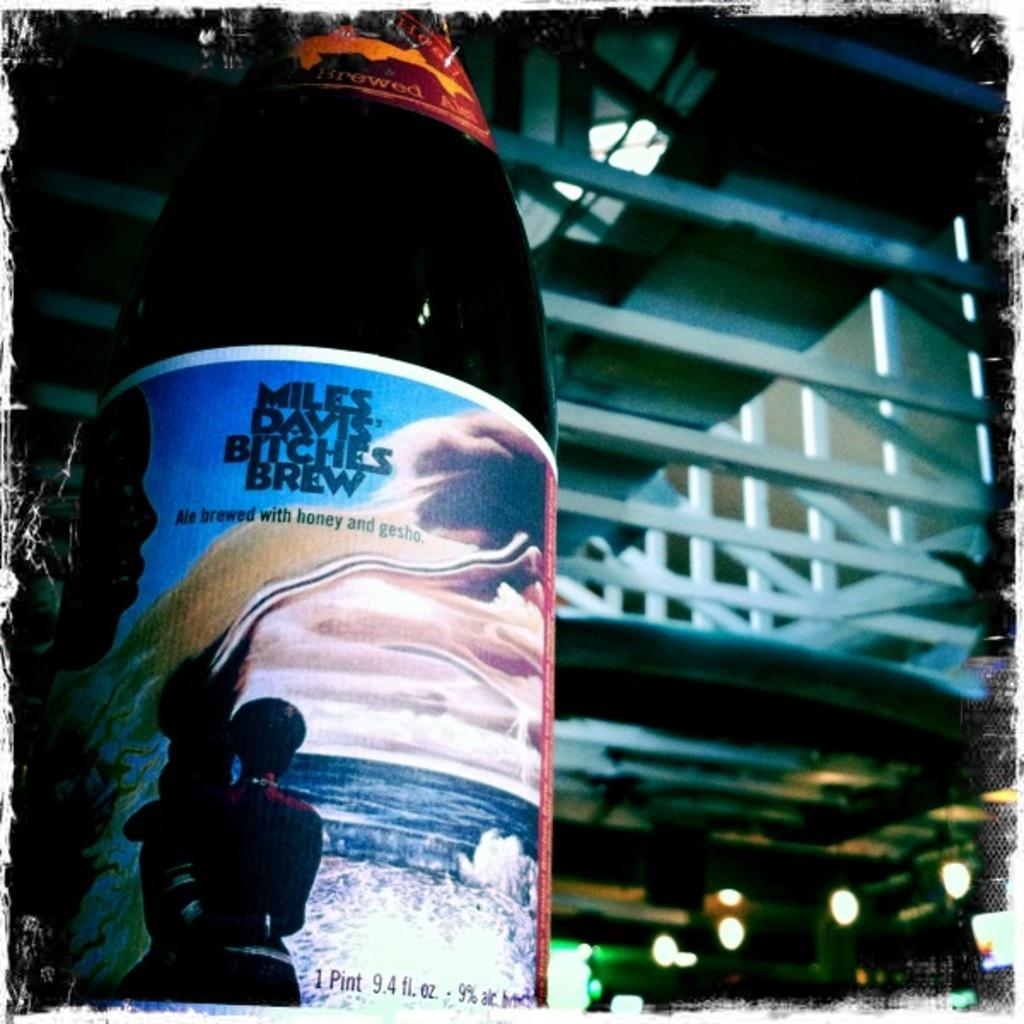<image>
Present a compact description of the photo's key features. A bottle of Miles Davis' Bitches brew in a warehouse. 